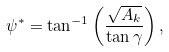Convert formula to latex. <formula><loc_0><loc_0><loc_500><loc_500>\psi ^ { * } = \tan ^ { - 1 } \left ( \frac { \sqrt { A _ { k } } } { \tan \gamma } \right ) ,</formula> 